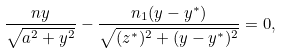Convert formula to latex. <formula><loc_0><loc_0><loc_500><loc_500>\frac { n y } { \sqrt { a ^ { 2 } + y ^ { 2 } } } - \frac { n _ { 1 } ( y - y ^ { * } ) } { \sqrt { ( z ^ { * } ) ^ { 2 } + ( y - y ^ { * } ) ^ { 2 } } } = 0 ,</formula> 